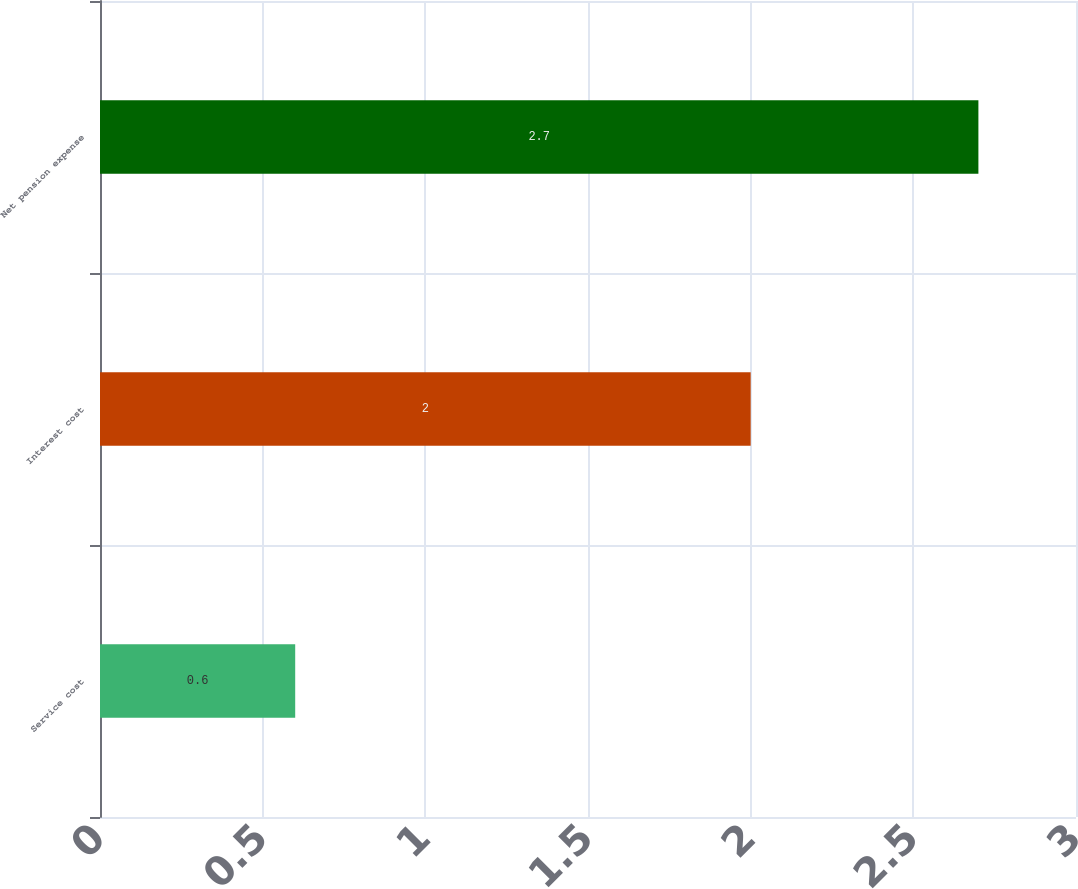<chart> <loc_0><loc_0><loc_500><loc_500><bar_chart><fcel>Service cost<fcel>Interest cost<fcel>Net pension expense<nl><fcel>0.6<fcel>2<fcel>2.7<nl></chart> 